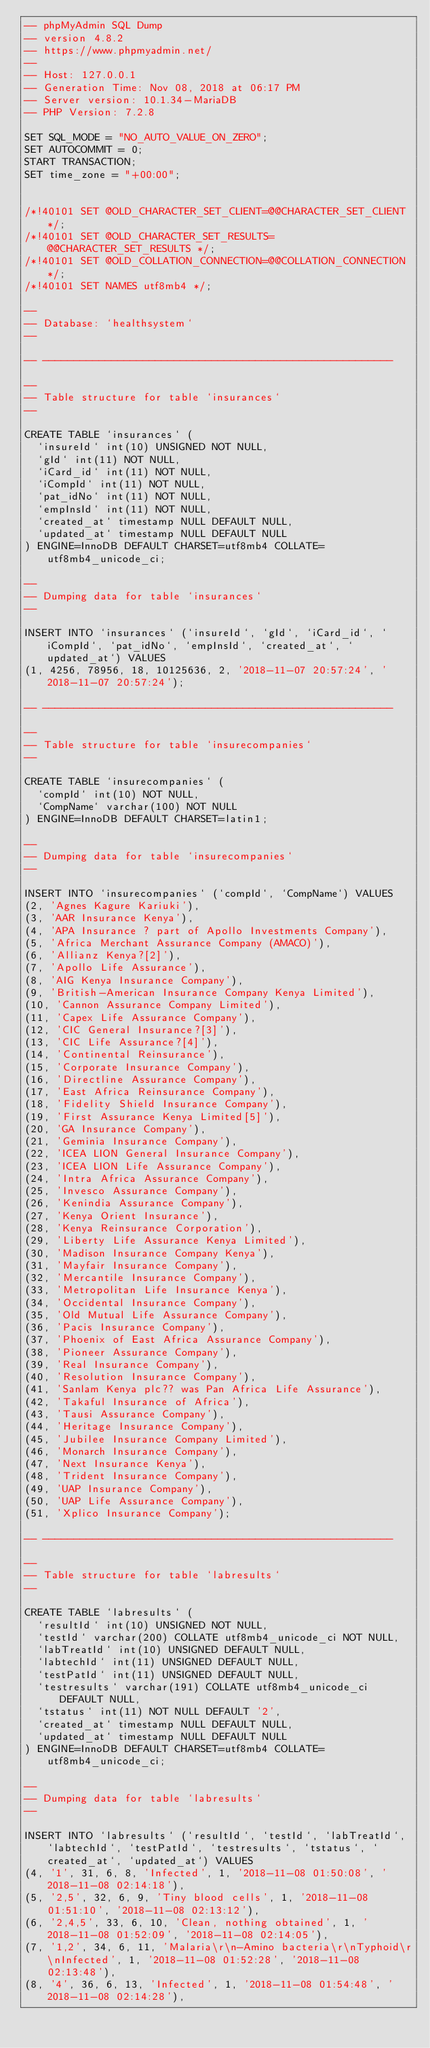<code> <loc_0><loc_0><loc_500><loc_500><_SQL_>-- phpMyAdmin SQL Dump
-- version 4.8.2
-- https://www.phpmyadmin.net/
--
-- Host: 127.0.0.1
-- Generation Time: Nov 08, 2018 at 06:17 PM
-- Server version: 10.1.34-MariaDB
-- PHP Version: 7.2.8

SET SQL_MODE = "NO_AUTO_VALUE_ON_ZERO";
SET AUTOCOMMIT = 0;
START TRANSACTION;
SET time_zone = "+00:00";


/*!40101 SET @OLD_CHARACTER_SET_CLIENT=@@CHARACTER_SET_CLIENT */;
/*!40101 SET @OLD_CHARACTER_SET_RESULTS=@@CHARACTER_SET_RESULTS */;
/*!40101 SET @OLD_COLLATION_CONNECTION=@@COLLATION_CONNECTION */;
/*!40101 SET NAMES utf8mb4 */;

--
-- Database: `healthsystem`
--

-- --------------------------------------------------------

--
-- Table structure for table `insurances`
--

CREATE TABLE `insurances` (
  `insureId` int(10) UNSIGNED NOT NULL,
  `gId` int(11) NOT NULL,
  `iCard_id` int(11) NOT NULL,
  `iCompId` int(11) NOT NULL,
  `pat_idNo` int(11) NOT NULL,
  `empInsId` int(11) NOT NULL,
  `created_at` timestamp NULL DEFAULT NULL,
  `updated_at` timestamp NULL DEFAULT NULL
) ENGINE=InnoDB DEFAULT CHARSET=utf8mb4 COLLATE=utf8mb4_unicode_ci;

--
-- Dumping data for table `insurances`
--

INSERT INTO `insurances` (`insureId`, `gId`, `iCard_id`, `iCompId`, `pat_idNo`, `empInsId`, `created_at`, `updated_at`) VALUES
(1, 4256, 78956, 18, 10125636, 2, '2018-11-07 20:57:24', '2018-11-07 20:57:24');

-- --------------------------------------------------------

--
-- Table structure for table `insurecompanies`
--

CREATE TABLE `insurecompanies` (
  `compId` int(10) NOT NULL,
  `CompName` varchar(100) NOT NULL
) ENGINE=InnoDB DEFAULT CHARSET=latin1;

--
-- Dumping data for table `insurecompanies`
--

INSERT INTO `insurecompanies` (`compId`, `CompName`) VALUES
(2, 'Agnes Kagure Kariuki'),
(3, 'AAR Insurance Kenya'),
(4, 'APA Insurance ? part of Apollo Investments Company'),
(5, 'Africa Merchant Assurance Company (AMACO)'),
(6, 'Allianz Kenya?[2]'),
(7, 'Apollo Life Assurance'),
(8, 'AIG Kenya Insurance Company'),
(9, 'British-American Insurance Company Kenya Limited'),
(10, 'Cannon Assurance Company Limited'),
(11, 'Capex Life Assurance Company'),
(12, 'CIC General Insurance?[3]'),
(13, 'CIC Life Assurance?[4]'),
(14, 'Continental Reinsurance'),
(15, 'Corporate Insurance Company'),
(16, 'Directline Assurance Company'),
(17, 'East Africa Reinsurance Company'),
(18, 'Fidelity Shield Insurance Company'),
(19, 'First Assurance Kenya Limited[5]'),
(20, 'GA Insurance Company'),
(21, 'Geminia Insurance Company'),
(22, 'ICEA LION General Insurance Company'),
(23, 'ICEA LION Life Assurance Company'),
(24, 'Intra Africa Assurance Company'),
(25, 'Invesco Assurance Company'),
(26, 'Kenindia Assurance Company'),
(27, 'Kenya Orient Insurance'),
(28, 'Kenya Reinsurance Corporation'),
(29, 'Liberty Life Assurance Kenya Limited'),
(30, 'Madison Insurance Company Kenya'),
(31, 'Mayfair Insurance Company'),
(32, 'Mercantile Insurance Company'),
(33, 'Metropolitan Life Insurance Kenya'),
(34, 'Occidental Insurance Company'),
(35, 'Old Mutual Life Assurance Company'),
(36, 'Pacis Insurance Company'),
(37, 'Phoenix of East Africa Assurance Company'),
(38, 'Pioneer Assurance Company'),
(39, 'Real Insurance Company'),
(40, 'Resolution Insurance Company'),
(41, 'Sanlam Kenya plc?? was Pan Africa Life Assurance'),
(42, 'Takaful Insurance of Africa'),
(43, 'Tausi Assurance Company'),
(44, 'Heritage Insurance Company'),
(45, 'Jubilee Insurance Company Limited'),
(46, 'Monarch Insurance Company'),
(47, 'Next Insurance Kenya'),
(48, 'Trident Insurance Company'),
(49, 'UAP Insurance Company'),
(50, 'UAP Life Assurance Company'),
(51, 'Xplico Insurance Company');

-- --------------------------------------------------------

--
-- Table structure for table `labresults`
--

CREATE TABLE `labresults` (
  `resultId` int(10) UNSIGNED NOT NULL,
  `testId` varchar(200) COLLATE utf8mb4_unicode_ci NOT NULL,
  `labTreatId` int(10) UNSIGNED DEFAULT NULL,
  `labtechId` int(11) UNSIGNED DEFAULT NULL,
  `testPatId` int(11) UNSIGNED DEFAULT NULL,
  `testresults` varchar(191) COLLATE utf8mb4_unicode_ci DEFAULT NULL,
  `tstatus` int(11) NOT NULL DEFAULT '2',
  `created_at` timestamp NULL DEFAULT NULL,
  `updated_at` timestamp NULL DEFAULT NULL
) ENGINE=InnoDB DEFAULT CHARSET=utf8mb4 COLLATE=utf8mb4_unicode_ci;

--
-- Dumping data for table `labresults`
--

INSERT INTO `labresults` (`resultId`, `testId`, `labTreatId`, `labtechId`, `testPatId`, `testresults`, `tstatus`, `created_at`, `updated_at`) VALUES
(4, '1', 31, 6, 8, 'Infected', 1, '2018-11-08 01:50:08', '2018-11-08 02:14:18'),
(5, '2,5', 32, 6, 9, 'Tiny blood cells', 1, '2018-11-08 01:51:10', '2018-11-08 02:13:12'),
(6, '2,4,5', 33, 6, 10, 'Clean, nothing obtained', 1, '2018-11-08 01:52:09', '2018-11-08 02:14:05'),
(7, '1,2', 34, 6, 11, 'Malaria\r\n-Amino bacteria\r\nTyphoid\r\nInfected', 1, '2018-11-08 01:52:28', '2018-11-08 02:13:48'),
(8, '4', 36, 6, 13, 'Infected', 1, '2018-11-08 01:54:48', '2018-11-08 02:14:28'),</code> 